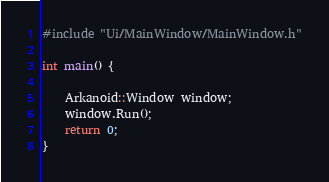<code> <loc_0><loc_0><loc_500><loc_500><_C++_>#include "Ui/MainWindow/MainWindow.h"

int main() {

	Arkanoid::Window window;
	window.Run();
	return 0;
}</code> 